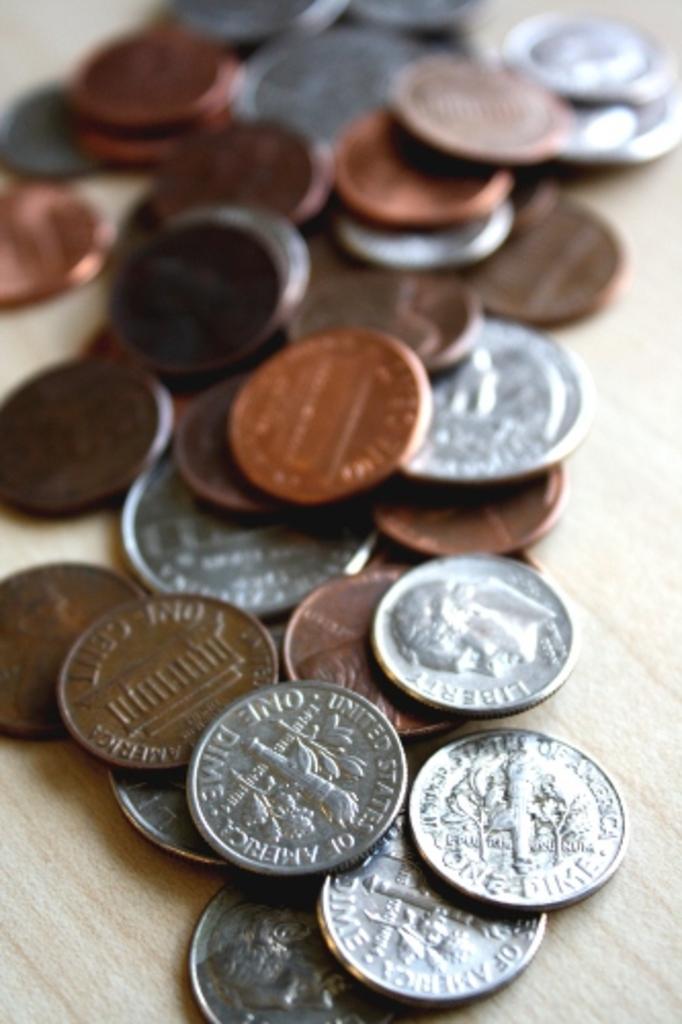Could you give a brief overview of what you see in this image? In this image we can see the coins on the wooden surface. 